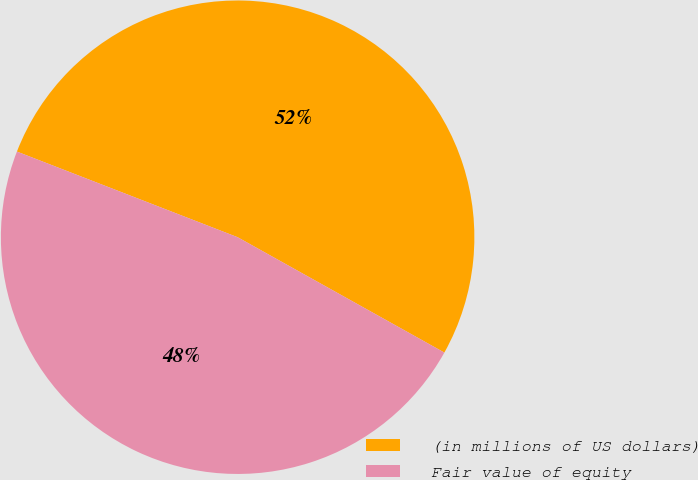Convert chart. <chart><loc_0><loc_0><loc_500><loc_500><pie_chart><fcel>(in millions of US dollars)<fcel>Fair value of equity<nl><fcel>52.21%<fcel>47.79%<nl></chart> 